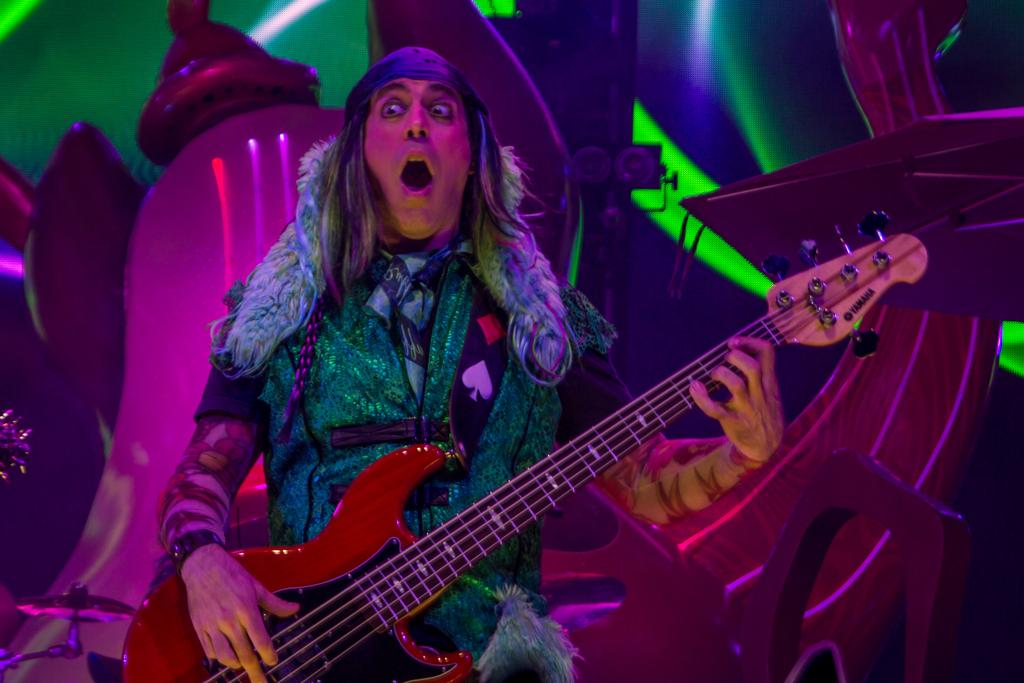What is the main subject of the image? The main subject of the image is a man. What is the man doing in the image? The man is standing and playing a guitar. What can be seen in the background of the image? There is a cymbal stand in the background of the image. What type of afterthought is the man having while playing the guitar in the image? There is no indication of any afterthought in the image; the man is simply playing the guitar. How many minutes has the man been playing the guitar in the image? The image does not provide any information about the duration of the man playing the guitar. 